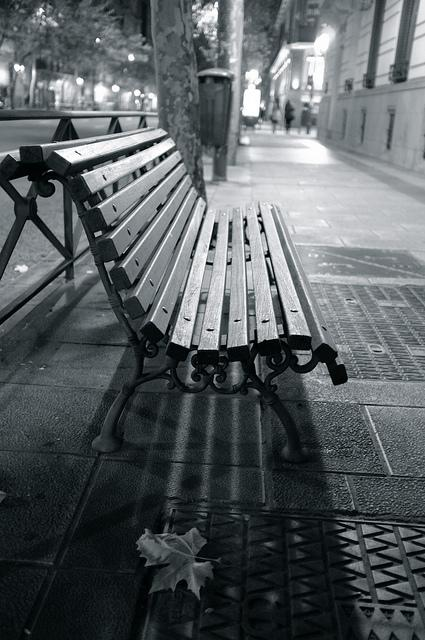In what area is this chair located? Please explain your reasoning. side walk. The nearby road and the pavement below the bench give away its location. 